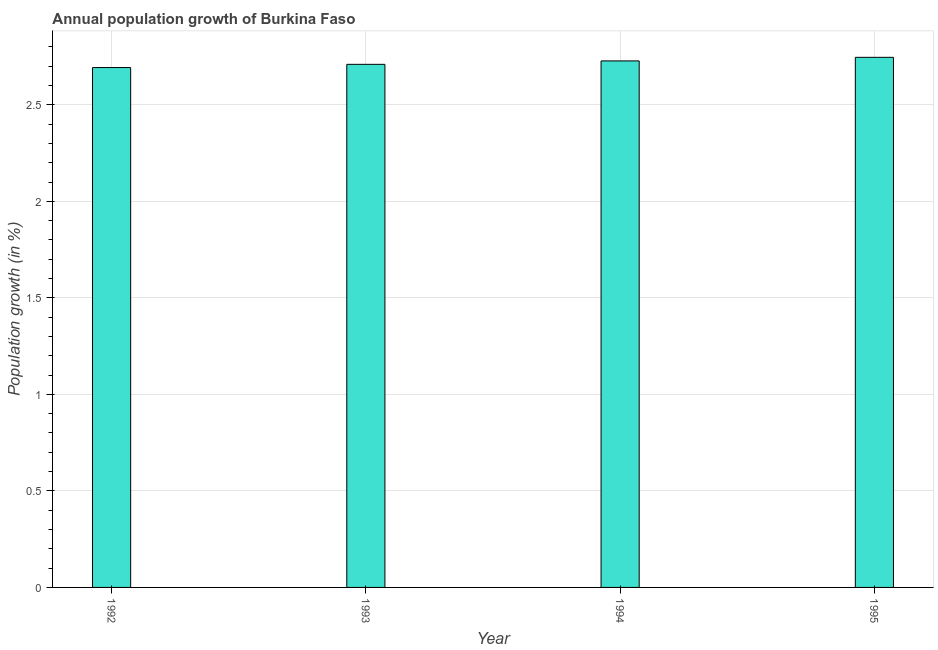Does the graph contain any zero values?
Your answer should be compact. No. Does the graph contain grids?
Your answer should be very brief. Yes. What is the title of the graph?
Offer a terse response. Annual population growth of Burkina Faso. What is the label or title of the X-axis?
Ensure brevity in your answer.  Year. What is the label or title of the Y-axis?
Offer a terse response. Population growth (in %). What is the population growth in 1994?
Your answer should be compact. 2.73. Across all years, what is the maximum population growth?
Your response must be concise. 2.75. Across all years, what is the minimum population growth?
Ensure brevity in your answer.  2.69. In which year was the population growth minimum?
Your answer should be very brief. 1992. What is the sum of the population growth?
Offer a terse response. 10.88. What is the difference between the population growth in 1992 and 1995?
Your response must be concise. -0.05. What is the average population growth per year?
Provide a succinct answer. 2.72. What is the median population growth?
Provide a short and direct response. 2.72. Do a majority of the years between 1993 and 1992 (inclusive) have population growth greater than 1 %?
Offer a very short reply. No. What is the ratio of the population growth in 1992 to that in 1995?
Your response must be concise. 0.98. Is the difference between the population growth in 1992 and 1994 greater than the difference between any two years?
Offer a very short reply. No. What is the difference between the highest and the second highest population growth?
Keep it short and to the point. 0.02. Is the sum of the population growth in 1992 and 1993 greater than the maximum population growth across all years?
Offer a very short reply. Yes. What is the difference between the highest and the lowest population growth?
Give a very brief answer. 0.05. In how many years, is the population growth greater than the average population growth taken over all years?
Provide a succinct answer. 2. Are all the bars in the graph horizontal?
Ensure brevity in your answer.  No. Are the values on the major ticks of Y-axis written in scientific E-notation?
Your answer should be very brief. No. What is the Population growth (in %) in 1992?
Your answer should be very brief. 2.69. What is the Population growth (in %) in 1993?
Keep it short and to the point. 2.71. What is the Population growth (in %) of 1994?
Your response must be concise. 2.73. What is the Population growth (in %) in 1995?
Provide a short and direct response. 2.75. What is the difference between the Population growth (in %) in 1992 and 1993?
Offer a terse response. -0.02. What is the difference between the Population growth (in %) in 1992 and 1994?
Offer a terse response. -0.03. What is the difference between the Population growth (in %) in 1992 and 1995?
Provide a short and direct response. -0.05. What is the difference between the Population growth (in %) in 1993 and 1994?
Keep it short and to the point. -0.02. What is the difference between the Population growth (in %) in 1993 and 1995?
Provide a short and direct response. -0.04. What is the difference between the Population growth (in %) in 1994 and 1995?
Keep it short and to the point. -0.02. What is the ratio of the Population growth (in %) in 1992 to that in 1994?
Keep it short and to the point. 0.99. What is the ratio of the Population growth (in %) in 1992 to that in 1995?
Your answer should be compact. 0.98. What is the ratio of the Population growth (in %) in 1993 to that in 1995?
Offer a very short reply. 0.99. 